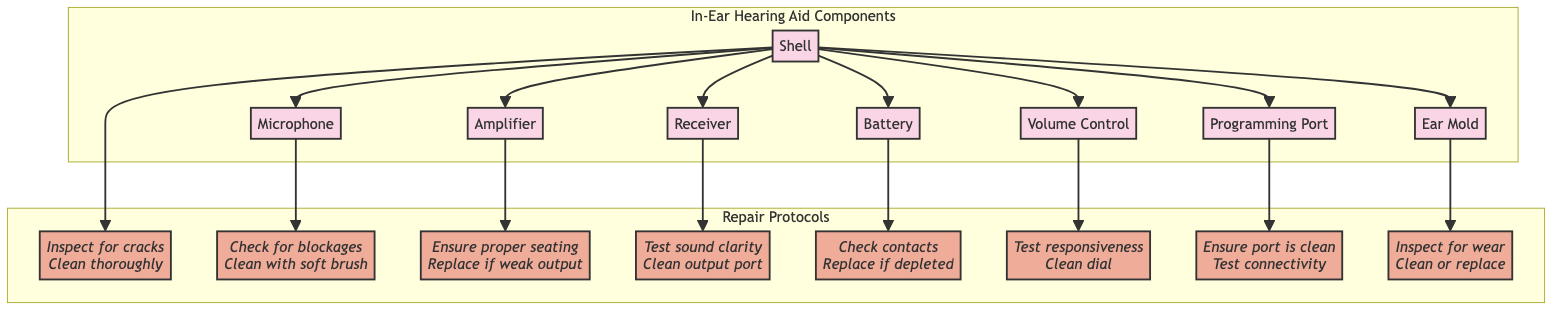What are the main components of the in-ear hearing aid? The diagram lists eight main components: Shell, Microphone, Amplifier, Receiver, Battery, Volume Control, Programming Port, and Ear Mold. These components are visually represented in a flowchart format.
Answer: Shell, Microphone, Amplifier, Receiver, Battery, Volume Control, Programming Port, Ear Mold How many protocols are associated with the in-ear hearing aid components? There are eight protocols corresponding to each of the components listed in the diagram, indicating that each component has a specific repair protocol.
Answer: Eight What component is connected to the Volume Control? The diagram shows that the Volume Control is directly connected to the Shell, indicating that the Shell serves as the base for the Volume Control's attachment.
Answer: Shell What is the protocol for cleaning the Microphone? The protocol for the Microphone indicates that it should be checked for blockages and cleaned with a soft brush, as described in the diagram.
Answer: Check for blockages, Clean with soft brush Which component requires testing for sound clarity? The Receiver is the component that needs to have sound clarity tested, as outlined in the repair protocol section of the diagram.
Answer: Receiver If the Battery is depleted, what should be done? According to the repair protocols, if the Battery is depleted, it must be replaced after checking the contacts to ensure proper connection.
Answer: Replace if depleted How many connections does the Shell make with other components? The Shell connects to seven other components, demonstrating its central role in the structure of the in-ear hearing aid.
Answer: Seven What is needed to ensure proper function at the Programming Port? The protocol states that the Programming Port needs to be ensured clean, and its connectivity should be tested for proper functioning.
Answer: Ensure port is clean, Test connectivity 